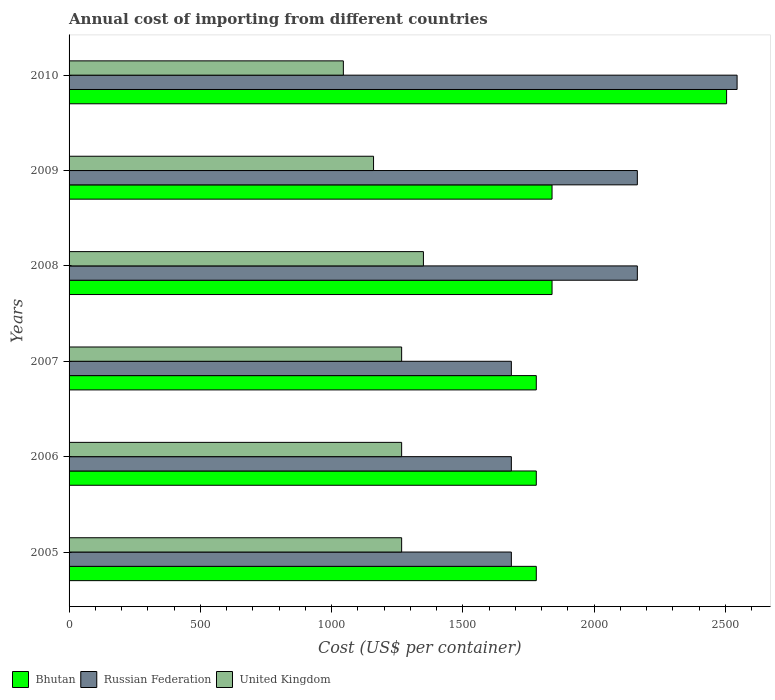Are the number of bars per tick equal to the number of legend labels?
Make the answer very short. Yes. Are the number of bars on each tick of the Y-axis equal?
Make the answer very short. Yes. How many bars are there on the 2nd tick from the top?
Offer a terse response. 3. How many bars are there on the 1st tick from the bottom?
Provide a short and direct response. 3. In how many cases, is the number of bars for a given year not equal to the number of legend labels?
Offer a terse response. 0. What is the total annual cost of importing in Russian Federation in 2009?
Keep it short and to the point. 2165. Across all years, what is the maximum total annual cost of importing in Bhutan?
Offer a terse response. 2505. Across all years, what is the minimum total annual cost of importing in Russian Federation?
Offer a very short reply. 1685. In which year was the total annual cost of importing in United Kingdom maximum?
Keep it short and to the point. 2008. In which year was the total annual cost of importing in United Kingdom minimum?
Your answer should be very brief. 2010. What is the total total annual cost of importing in Russian Federation in the graph?
Offer a terse response. 1.19e+04. What is the difference between the total annual cost of importing in Russian Federation in 2006 and that in 2009?
Make the answer very short. -480. What is the difference between the total annual cost of importing in Russian Federation in 2010 and the total annual cost of importing in United Kingdom in 2007?
Give a very brief answer. 1278. What is the average total annual cost of importing in Bhutan per year?
Your response must be concise. 1920.83. In the year 2007, what is the difference between the total annual cost of importing in Bhutan and total annual cost of importing in United Kingdom?
Offer a very short reply. 513. In how many years, is the total annual cost of importing in Bhutan greater than 1700 US$?
Give a very brief answer. 6. What is the ratio of the total annual cost of importing in United Kingdom in 2007 to that in 2010?
Your response must be concise. 1.21. What is the difference between the highest and the second highest total annual cost of importing in Bhutan?
Ensure brevity in your answer.  665. What is the difference between the highest and the lowest total annual cost of importing in United Kingdom?
Provide a short and direct response. 305. In how many years, is the total annual cost of importing in United Kingdom greater than the average total annual cost of importing in United Kingdom taken over all years?
Offer a very short reply. 4. What does the 3rd bar from the top in 2007 represents?
Provide a short and direct response. Bhutan. What does the 1st bar from the bottom in 2008 represents?
Your response must be concise. Bhutan. Is it the case that in every year, the sum of the total annual cost of importing in Bhutan and total annual cost of importing in Russian Federation is greater than the total annual cost of importing in United Kingdom?
Your answer should be compact. Yes. How many years are there in the graph?
Offer a very short reply. 6. What is the difference between two consecutive major ticks on the X-axis?
Provide a succinct answer. 500. Where does the legend appear in the graph?
Provide a succinct answer. Bottom left. How are the legend labels stacked?
Your answer should be compact. Horizontal. What is the title of the graph?
Offer a terse response. Annual cost of importing from different countries. Does "Guinea-Bissau" appear as one of the legend labels in the graph?
Give a very brief answer. No. What is the label or title of the X-axis?
Keep it short and to the point. Cost (US$ per container). What is the Cost (US$ per container) of Bhutan in 2005?
Make the answer very short. 1780. What is the Cost (US$ per container) in Russian Federation in 2005?
Your response must be concise. 1685. What is the Cost (US$ per container) in United Kingdom in 2005?
Give a very brief answer. 1267. What is the Cost (US$ per container) in Bhutan in 2006?
Ensure brevity in your answer.  1780. What is the Cost (US$ per container) in Russian Federation in 2006?
Offer a very short reply. 1685. What is the Cost (US$ per container) in United Kingdom in 2006?
Provide a short and direct response. 1267. What is the Cost (US$ per container) in Bhutan in 2007?
Your response must be concise. 1780. What is the Cost (US$ per container) of Russian Federation in 2007?
Offer a very short reply. 1685. What is the Cost (US$ per container) in United Kingdom in 2007?
Keep it short and to the point. 1267. What is the Cost (US$ per container) of Bhutan in 2008?
Your answer should be very brief. 1840. What is the Cost (US$ per container) of Russian Federation in 2008?
Your answer should be compact. 2165. What is the Cost (US$ per container) in United Kingdom in 2008?
Offer a very short reply. 1350. What is the Cost (US$ per container) in Bhutan in 2009?
Your response must be concise. 1840. What is the Cost (US$ per container) in Russian Federation in 2009?
Provide a succinct answer. 2165. What is the Cost (US$ per container) of United Kingdom in 2009?
Provide a short and direct response. 1160. What is the Cost (US$ per container) in Bhutan in 2010?
Your response must be concise. 2505. What is the Cost (US$ per container) of Russian Federation in 2010?
Keep it short and to the point. 2545. What is the Cost (US$ per container) of United Kingdom in 2010?
Provide a short and direct response. 1045. Across all years, what is the maximum Cost (US$ per container) in Bhutan?
Offer a terse response. 2505. Across all years, what is the maximum Cost (US$ per container) of Russian Federation?
Make the answer very short. 2545. Across all years, what is the maximum Cost (US$ per container) of United Kingdom?
Offer a very short reply. 1350. Across all years, what is the minimum Cost (US$ per container) in Bhutan?
Your answer should be compact. 1780. Across all years, what is the minimum Cost (US$ per container) in Russian Federation?
Your answer should be compact. 1685. Across all years, what is the minimum Cost (US$ per container) in United Kingdom?
Ensure brevity in your answer.  1045. What is the total Cost (US$ per container) in Bhutan in the graph?
Your response must be concise. 1.15e+04. What is the total Cost (US$ per container) in Russian Federation in the graph?
Provide a succinct answer. 1.19e+04. What is the total Cost (US$ per container) in United Kingdom in the graph?
Give a very brief answer. 7356. What is the difference between the Cost (US$ per container) of Bhutan in 2005 and that in 2006?
Ensure brevity in your answer.  0. What is the difference between the Cost (US$ per container) in Russian Federation in 2005 and that in 2006?
Your response must be concise. 0. What is the difference between the Cost (US$ per container) in Bhutan in 2005 and that in 2007?
Your answer should be very brief. 0. What is the difference between the Cost (US$ per container) in Russian Federation in 2005 and that in 2007?
Offer a very short reply. 0. What is the difference between the Cost (US$ per container) of United Kingdom in 2005 and that in 2007?
Your answer should be compact. 0. What is the difference between the Cost (US$ per container) of Bhutan in 2005 and that in 2008?
Give a very brief answer. -60. What is the difference between the Cost (US$ per container) of Russian Federation in 2005 and that in 2008?
Your response must be concise. -480. What is the difference between the Cost (US$ per container) in United Kingdom in 2005 and that in 2008?
Offer a very short reply. -83. What is the difference between the Cost (US$ per container) in Bhutan in 2005 and that in 2009?
Make the answer very short. -60. What is the difference between the Cost (US$ per container) in Russian Federation in 2005 and that in 2009?
Make the answer very short. -480. What is the difference between the Cost (US$ per container) of United Kingdom in 2005 and that in 2009?
Give a very brief answer. 107. What is the difference between the Cost (US$ per container) in Bhutan in 2005 and that in 2010?
Give a very brief answer. -725. What is the difference between the Cost (US$ per container) of Russian Federation in 2005 and that in 2010?
Offer a terse response. -860. What is the difference between the Cost (US$ per container) in United Kingdom in 2005 and that in 2010?
Your answer should be compact. 222. What is the difference between the Cost (US$ per container) of Bhutan in 2006 and that in 2007?
Offer a very short reply. 0. What is the difference between the Cost (US$ per container) in Bhutan in 2006 and that in 2008?
Provide a short and direct response. -60. What is the difference between the Cost (US$ per container) in Russian Federation in 2006 and that in 2008?
Give a very brief answer. -480. What is the difference between the Cost (US$ per container) in United Kingdom in 2006 and that in 2008?
Your answer should be compact. -83. What is the difference between the Cost (US$ per container) in Bhutan in 2006 and that in 2009?
Your answer should be compact. -60. What is the difference between the Cost (US$ per container) of Russian Federation in 2006 and that in 2009?
Offer a terse response. -480. What is the difference between the Cost (US$ per container) of United Kingdom in 2006 and that in 2009?
Your answer should be very brief. 107. What is the difference between the Cost (US$ per container) of Bhutan in 2006 and that in 2010?
Provide a short and direct response. -725. What is the difference between the Cost (US$ per container) of Russian Federation in 2006 and that in 2010?
Keep it short and to the point. -860. What is the difference between the Cost (US$ per container) of United Kingdom in 2006 and that in 2010?
Ensure brevity in your answer.  222. What is the difference between the Cost (US$ per container) in Bhutan in 2007 and that in 2008?
Make the answer very short. -60. What is the difference between the Cost (US$ per container) in Russian Federation in 2007 and that in 2008?
Make the answer very short. -480. What is the difference between the Cost (US$ per container) in United Kingdom in 2007 and that in 2008?
Make the answer very short. -83. What is the difference between the Cost (US$ per container) of Bhutan in 2007 and that in 2009?
Provide a succinct answer. -60. What is the difference between the Cost (US$ per container) of Russian Federation in 2007 and that in 2009?
Your answer should be very brief. -480. What is the difference between the Cost (US$ per container) in United Kingdom in 2007 and that in 2009?
Offer a very short reply. 107. What is the difference between the Cost (US$ per container) of Bhutan in 2007 and that in 2010?
Make the answer very short. -725. What is the difference between the Cost (US$ per container) in Russian Federation in 2007 and that in 2010?
Your response must be concise. -860. What is the difference between the Cost (US$ per container) of United Kingdom in 2007 and that in 2010?
Provide a short and direct response. 222. What is the difference between the Cost (US$ per container) in Russian Federation in 2008 and that in 2009?
Provide a short and direct response. 0. What is the difference between the Cost (US$ per container) in United Kingdom in 2008 and that in 2009?
Provide a short and direct response. 190. What is the difference between the Cost (US$ per container) in Bhutan in 2008 and that in 2010?
Give a very brief answer. -665. What is the difference between the Cost (US$ per container) of Russian Federation in 2008 and that in 2010?
Make the answer very short. -380. What is the difference between the Cost (US$ per container) of United Kingdom in 2008 and that in 2010?
Offer a terse response. 305. What is the difference between the Cost (US$ per container) in Bhutan in 2009 and that in 2010?
Provide a short and direct response. -665. What is the difference between the Cost (US$ per container) in Russian Federation in 2009 and that in 2010?
Give a very brief answer. -380. What is the difference between the Cost (US$ per container) in United Kingdom in 2009 and that in 2010?
Offer a very short reply. 115. What is the difference between the Cost (US$ per container) of Bhutan in 2005 and the Cost (US$ per container) of Russian Federation in 2006?
Provide a succinct answer. 95. What is the difference between the Cost (US$ per container) of Bhutan in 2005 and the Cost (US$ per container) of United Kingdom in 2006?
Keep it short and to the point. 513. What is the difference between the Cost (US$ per container) of Russian Federation in 2005 and the Cost (US$ per container) of United Kingdom in 2006?
Ensure brevity in your answer.  418. What is the difference between the Cost (US$ per container) of Bhutan in 2005 and the Cost (US$ per container) of United Kingdom in 2007?
Offer a terse response. 513. What is the difference between the Cost (US$ per container) in Russian Federation in 2005 and the Cost (US$ per container) in United Kingdom in 2007?
Keep it short and to the point. 418. What is the difference between the Cost (US$ per container) in Bhutan in 2005 and the Cost (US$ per container) in Russian Federation in 2008?
Your response must be concise. -385. What is the difference between the Cost (US$ per container) of Bhutan in 2005 and the Cost (US$ per container) of United Kingdom in 2008?
Your answer should be compact. 430. What is the difference between the Cost (US$ per container) of Russian Federation in 2005 and the Cost (US$ per container) of United Kingdom in 2008?
Provide a short and direct response. 335. What is the difference between the Cost (US$ per container) of Bhutan in 2005 and the Cost (US$ per container) of Russian Federation in 2009?
Your response must be concise. -385. What is the difference between the Cost (US$ per container) of Bhutan in 2005 and the Cost (US$ per container) of United Kingdom in 2009?
Keep it short and to the point. 620. What is the difference between the Cost (US$ per container) of Russian Federation in 2005 and the Cost (US$ per container) of United Kingdom in 2009?
Provide a succinct answer. 525. What is the difference between the Cost (US$ per container) of Bhutan in 2005 and the Cost (US$ per container) of Russian Federation in 2010?
Provide a short and direct response. -765. What is the difference between the Cost (US$ per container) of Bhutan in 2005 and the Cost (US$ per container) of United Kingdom in 2010?
Offer a very short reply. 735. What is the difference between the Cost (US$ per container) of Russian Federation in 2005 and the Cost (US$ per container) of United Kingdom in 2010?
Your answer should be compact. 640. What is the difference between the Cost (US$ per container) of Bhutan in 2006 and the Cost (US$ per container) of Russian Federation in 2007?
Your answer should be compact. 95. What is the difference between the Cost (US$ per container) of Bhutan in 2006 and the Cost (US$ per container) of United Kingdom in 2007?
Your answer should be compact. 513. What is the difference between the Cost (US$ per container) in Russian Federation in 2006 and the Cost (US$ per container) in United Kingdom in 2007?
Provide a succinct answer. 418. What is the difference between the Cost (US$ per container) in Bhutan in 2006 and the Cost (US$ per container) in Russian Federation in 2008?
Your response must be concise. -385. What is the difference between the Cost (US$ per container) of Bhutan in 2006 and the Cost (US$ per container) of United Kingdom in 2008?
Give a very brief answer. 430. What is the difference between the Cost (US$ per container) of Russian Federation in 2006 and the Cost (US$ per container) of United Kingdom in 2008?
Ensure brevity in your answer.  335. What is the difference between the Cost (US$ per container) in Bhutan in 2006 and the Cost (US$ per container) in Russian Federation in 2009?
Provide a succinct answer. -385. What is the difference between the Cost (US$ per container) in Bhutan in 2006 and the Cost (US$ per container) in United Kingdom in 2009?
Offer a terse response. 620. What is the difference between the Cost (US$ per container) in Russian Federation in 2006 and the Cost (US$ per container) in United Kingdom in 2009?
Your response must be concise. 525. What is the difference between the Cost (US$ per container) in Bhutan in 2006 and the Cost (US$ per container) in Russian Federation in 2010?
Your answer should be compact. -765. What is the difference between the Cost (US$ per container) in Bhutan in 2006 and the Cost (US$ per container) in United Kingdom in 2010?
Offer a very short reply. 735. What is the difference between the Cost (US$ per container) of Russian Federation in 2006 and the Cost (US$ per container) of United Kingdom in 2010?
Offer a very short reply. 640. What is the difference between the Cost (US$ per container) in Bhutan in 2007 and the Cost (US$ per container) in Russian Federation in 2008?
Provide a short and direct response. -385. What is the difference between the Cost (US$ per container) in Bhutan in 2007 and the Cost (US$ per container) in United Kingdom in 2008?
Your answer should be compact. 430. What is the difference between the Cost (US$ per container) of Russian Federation in 2007 and the Cost (US$ per container) of United Kingdom in 2008?
Your answer should be very brief. 335. What is the difference between the Cost (US$ per container) of Bhutan in 2007 and the Cost (US$ per container) of Russian Federation in 2009?
Give a very brief answer. -385. What is the difference between the Cost (US$ per container) in Bhutan in 2007 and the Cost (US$ per container) in United Kingdom in 2009?
Offer a very short reply. 620. What is the difference between the Cost (US$ per container) of Russian Federation in 2007 and the Cost (US$ per container) of United Kingdom in 2009?
Offer a terse response. 525. What is the difference between the Cost (US$ per container) in Bhutan in 2007 and the Cost (US$ per container) in Russian Federation in 2010?
Your answer should be compact. -765. What is the difference between the Cost (US$ per container) in Bhutan in 2007 and the Cost (US$ per container) in United Kingdom in 2010?
Your response must be concise. 735. What is the difference between the Cost (US$ per container) in Russian Federation in 2007 and the Cost (US$ per container) in United Kingdom in 2010?
Provide a short and direct response. 640. What is the difference between the Cost (US$ per container) in Bhutan in 2008 and the Cost (US$ per container) in Russian Federation in 2009?
Offer a terse response. -325. What is the difference between the Cost (US$ per container) in Bhutan in 2008 and the Cost (US$ per container) in United Kingdom in 2009?
Make the answer very short. 680. What is the difference between the Cost (US$ per container) in Russian Federation in 2008 and the Cost (US$ per container) in United Kingdom in 2009?
Ensure brevity in your answer.  1005. What is the difference between the Cost (US$ per container) in Bhutan in 2008 and the Cost (US$ per container) in Russian Federation in 2010?
Keep it short and to the point. -705. What is the difference between the Cost (US$ per container) in Bhutan in 2008 and the Cost (US$ per container) in United Kingdom in 2010?
Offer a terse response. 795. What is the difference between the Cost (US$ per container) of Russian Federation in 2008 and the Cost (US$ per container) of United Kingdom in 2010?
Your response must be concise. 1120. What is the difference between the Cost (US$ per container) in Bhutan in 2009 and the Cost (US$ per container) in Russian Federation in 2010?
Your answer should be very brief. -705. What is the difference between the Cost (US$ per container) in Bhutan in 2009 and the Cost (US$ per container) in United Kingdom in 2010?
Provide a succinct answer. 795. What is the difference between the Cost (US$ per container) of Russian Federation in 2009 and the Cost (US$ per container) of United Kingdom in 2010?
Your response must be concise. 1120. What is the average Cost (US$ per container) in Bhutan per year?
Your answer should be compact. 1920.83. What is the average Cost (US$ per container) in Russian Federation per year?
Provide a succinct answer. 1988.33. What is the average Cost (US$ per container) in United Kingdom per year?
Keep it short and to the point. 1226. In the year 2005, what is the difference between the Cost (US$ per container) of Bhutan and Cost (US$ per container) of Russian Federation?
Offer a terse response. 95. In the year 2005, what is the difference between the Cost (US$ per container) in Bhutan and Cost (US$ per container) in United Kingdom?
Make the answer very short. 513. In the year 2005, what is the difference between the Cost (US$ per container) in Russian Federation and Cost (US$ per container) in United Kingdom?
Ensure brevity in your answer.  418. In the year 2006, what is the difference between the Cost (US$ per container) of Bhutan and Cost (US$ per container) of United Kingdom?
Provide a succinct answer. 513. In the year 2006, what is the difference between the Cost (US$ per container) in Russian Federation and Cost (US$ per container) in United Kingdom?
Ensure brevity in your answer.  418. In the year 2007, what is the difference between the Cost (US$ per container) in Bhutan and Cost (US$ per container) in Russian Federation?
Offer a terse response. 95. In the year 2007, what is the difference between the Cost (US$ per container) of Bhutan and Cost (US$ per container) of United Kingdom?
Offer a terse response. 513. In the year 2007, what is the difference between the Cost (US$ per container) in Russian Federation and Cost (US$ per container) in United Kingdom?
Give a very brief answer. 418. In the year 2008, what is the difference between the Cost (US$ per container) in Bhutan and Cost (US$ per container) in Russian Federation?
Offer a terse response. -325. In the year 2008, what is the difference between the Cost (US$ per container) of Bhutan and Cost (US$ per container) of United Kingdom?
Your answer should be compact. 490. In the year 2008, what is the difference between the Cost (US$ per container) of Russian Federation and Cost (US$ per container) of United Kingdom?
Ensure brevity in your answer.  815. In the year 2009, what is the difference between the Cost (US$ per container) in Bhutan and Cost (US$ per container) in Russian Federation?
Keep it short and to the point. -325. In the year 2009, what is the difference between the Cost (US$ per container) of Bhutan and Cost (US$ per container) of United Kingdom?
Provide a succinct answer. 680. In the year 2009, what is the difference between the Cost (US$ per container) in Russian Federation and Cost (US$ per container) in United Kingdom?
Offer a terse response. 1005. In the year 2010, what is the difference between the Cost (US$ per container) in Bhutan and Cost (US$ per container) in Russian Federation?
Give a very brief answer. -40. In the year 2010, what is the difference between the Cost (US$ per container) of Bhutan and Cost (US$ per container) of United Kingdom?
Give a very brief answer. 1460. In the year 2010, what is the difference between the Cost (US$ per container) in Russian Federation and Cost (US$ per container) in United Kingdom?
Offer a very short reply. 1500. What is the ratio of the Cost (US$ per container) of United Kingdom in 2005 to that in 2006?
Make the answer very short. 1. What is the ratio of the Cost (US$ per container) in Bhutan in 2005 to that in 2007?
Make the answer very short. 1. What is the ratio of the Cost (US$ per container) in Russian Federation in 2005 to that in 2007?
Your response must be concise. 1. What is the ratio of the Cost (US$ per container) in United Kingdom in 2005 to that in 2007?
Offer a terse response. 1. What is the ratio of the Cost (US$ per container) in Bhutan in 2005 to that in 2008?
Provide a succinct answer. 0.97. What is the ratio of the Cost (US$ per container) in Russian Federation in 2005 to that in 2008?
Offer a very short reply. 0.78. What is the ratio of the Cost (US$ per container) of United Kingdom in 2005 to that in 2008?
Keep it short and to the point. 0.94. What is the ratio of the Cost (US$ per container) of Bhutan in 2005 to that in 2009?
Make the answer very short. 0.97. What is the ratio of the Cost (US$ per container) of Russian Federation in 2005 to that in 2009?
Your answer should be compact. 0.78. What is the ratio of the Cost (US$ per container) in United Kingdom in 2005 to that in 2009?
Provide a short and direct response. 1.09. What is the ratio of the Cost (US$ per container) of Bhutan in 2005 to that in 2010?
Your answer should be very brief. 0.71. What is the ratio of the Cost (US$ per container) of Russian Federation in 2005 to that in 2010?
Your answer should be very brief. 0.66. What is the ratio of the Cost (US$ per container) of United Kingdom in 2005 to that in 2010?
Keep it short and to the point. 1.21. What is the ratio of the Cost (US$ per container) of Russian Federation in 2006 to that in 2007?
Give a very brief answer. 1. What is the ratio of the Cost (US$ per container) of Bhutan in 2006 to that in 2008?
Provide a short and direct response. 0.97. What is the ratio of the Cost (US$ per container) in Russian Federation in 2006 to that in 2008?
Offer a terse response. 0.78. What is the ratio of the Cost (US$ per container) in United Kingdom in 2006 to that in 2008?
Offer a very short reply. 0.94. What is the ratio of the Cost (US$ per container) of Bhutan in 2006 to that in 2009?
Your response must be concise. 0.97. What is the ratio of the Cost (US$ per container) of Russian Federation in 2006 to that in 2009?
Your answer should be compact. 0.78. What is the ratio of the Cost (US$ per container) in United Kingdom in 2006 to that in 2009?
Give a very brief answer. 1.09. What is the ratio of the Cost (US$ per container) in Bhutan in 2006 to that in 2010?
Ensure brevity in your answer.  0.71. What is the ratio of the Cost (US$ per container) in Russian Federation in 2006 to that in 2010?
Provide a succinct answer. 0.66. What is the ratio of the Cost (US$ per container) in United Kingdom in 2006 to that in 2010?
Your answer should be compact. 1.21. What is the ratio of the Cost (US$ per container) of Bhutan in 2007 to that in 2008?
Your response must be concise. 0.97. What is the ratio of the Cost (US$ per container) of Russian Federation in 2007 to that in 2008?
Offer a very short reply. 0.78. What is the ratio of the Cost (US$ per container) of United Kingdom in 2007 to that in 2008?
Provide a short and direct response. 0.94. What is the ratio of the Cost (US$ per container) of Bhutan in 2007 to that in 2009?
Offer a very short reply. 0.97. What is the ratio of the Cost (US$ per container) in Russian Federation in 2007 to that in 2009?
Your answer should be compact. 0.78. What is the ratio of the Cost (US$ per container) of United Kingdom in 2007 to that in 2009?
Provide a succinct answer. 1.09. What is the ratio of the Cost (US$ per container) in Bhutan in 2007 to that in 2010?
Make the answer very short. 0.71. What is the ratio of the Cost (US$ per container) of Russian Federation in 2007 to that in 2010?
Provide a succinct answer. 0.66. What is the ratio of the Cost (US$ per container) in United Kingdom in 2007 to that in 2010?
Offer a terse response. 1.21. What is the ratio of the Cost (US$ per container) in Bhutan in 2008 to that in 2009?
Ensure brevity in your answer.  1. What is the ratio of the Cost (US$ per container) in Russian Federation in 2008 to that in 2009?
Offer a very short reply. 1. What is the ratio of the Cost (US$ per container) of United Kingdom in 2008 to that in 2009?
Provide a short and direct response. 1.16. What is the ratio of the Cost (US$ per container) of Bhutan in 2008 to that in 2010?
Make the answer very short. 0.73. What is the ratio of the Cost (US$ per container) in Russian Federation in 2008 to that in 2010?
Your response must be concise. 0.85. What is the ratio of the Cost (US$ per container) of United Kingdom in 2008 to that in 2010?
Your answer should be very brief. 1.29. What is the ratio of the Cost (US$ per container) of Bhutan in 2009 to that in 2010?
Provide a short and direct response. 0.73. What is the ratio of the Cost (US$ per container) of Russian Federation in 2009 to that in 2010?
Provide a short and direct response. 0.85. What is the ratio of the Cost (US$ per container) of United Kingdom in 2009 to that in 2010?
Provide a short and direct response. 1.11. What is the difference between the highest and the second highest Cost (US$ per container) of Bhutan?
Make the answer very short. 665. What is the difference between the highest and the second highest Cost (US$ per container) in Russian Federation?
Your answer should be compact. 380. What is the difference between the highest and the second highest Cost (US$ per container) in United Kingdom?
Make the answer very short. 83. What is the difference between the highest and the lowest Cost (US$ per container) of Bhutan?
Your response must be concise. 725. What is the difference between the highest and the lowest Cost (US$ per container) of Russian Federation?
Your answer should be very brief. 860. What is the difference between the highest and the lowest Cost (US$ per container) of United Kingdom?
Provide a short and direct response. 305. 